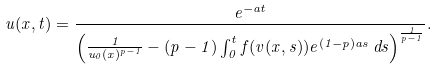Convert formula to latex. <formula><loc_0><loc_0><loc_500><loc_500>u ( x , t ) = \frac { e ^ { - a t } } { \left ( \frac { 1 } { u _ { 0 } ( x ) ^ { p - 1 } } - ( p - 1 ) \int _ { 0 } ^ { t } f ( v ( x , s ) ) e ^ { ( 1 - p ) a s } \, d s \right ) ^ { \frac { 1 } { p - 1 } } } .</formula> 